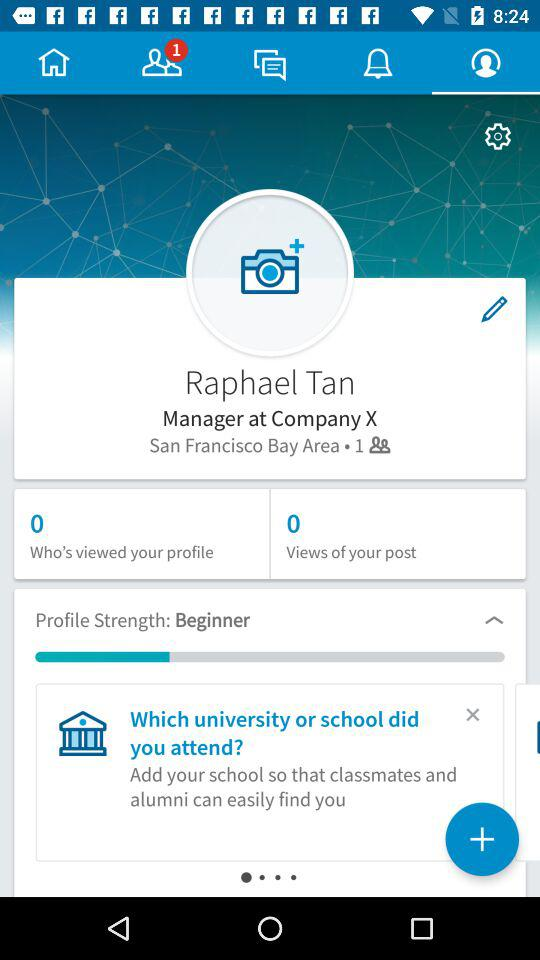How many more followers does Raphael Tan have than views of his post?
Answer the question using a single word or phrase. 1 